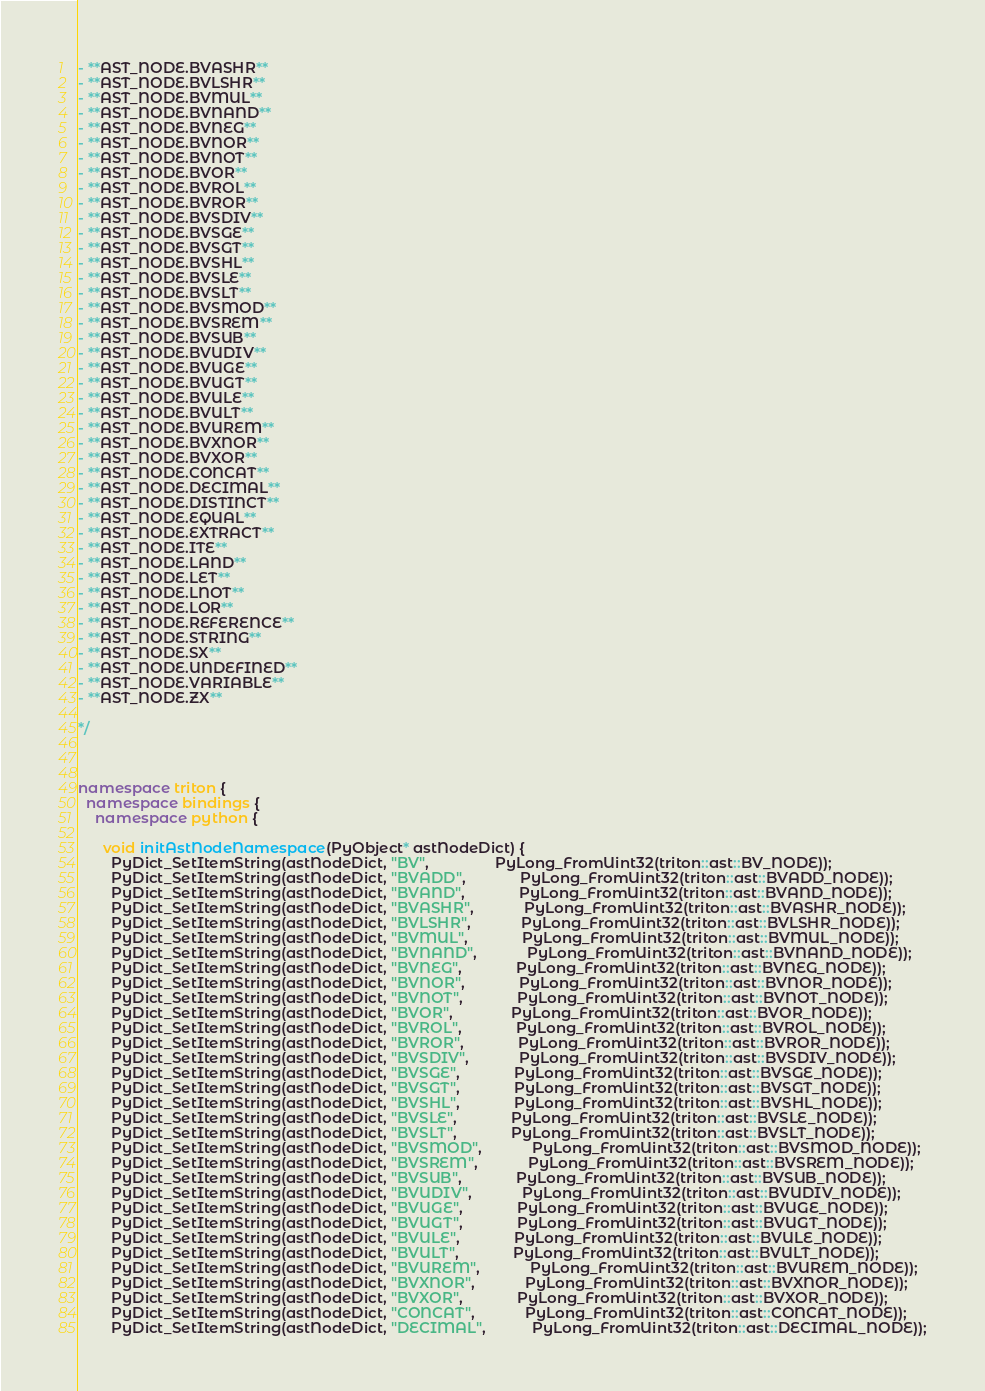<code> <loc_0><loc_0><loc_500><loc_500><_C++_>- **AST_NODE.BVASHR**
- **AST_NODE.BVLSHR**
- **AST_NODE.BVMUL**
- **AST_NODE.BVNAND**
- **AST_NODE.BVNEG**
- **AST_NODE.BVNOR**
- **AST_NODE.BVNOT**
- **AST_NODE.BVOR**
- **AST_NODE.BVROL**
- **AST_NODE.BVROR**
- **AST_NODE.BVSDIV**
- **AST_NODE.BVSGE**
- **AST_NODE.BVSGT**
- **AST_NODE.BVSHL**
- **AST_NODE.BVSLE**
- **AST_NODE.BVSLT**
- **AST_NODE.BVSMOD**
- **AST_NODE.BVSREM**
- **AST_NODE.BVSUB**
- **AST_NODE.BVUDIV**
- **AST_NODE.BVUGE**
- **AST_NODE.BVUGT**
- **AST_NODE.BVULE**
- **AST_NODE.BVULT**
- **AST_NODE.BVUREM**
- **AST_NODE.BVXNOR**
- **AST_NODE.BVXOR**
- **AST_NODE.CONCAT**
- **AST_NODE.DECIMAL**
- **AST_NODE.DISTINCT**
- **AST_NODE.EQUAL**
- **AST_NODE.EXTRACT**
- **AST_NODE.ITE**
- **AST_NODE.LAND**
- **AST_NODE.LET**
- **AST_NODE.LNOT**
- **AST_NODE.LOR**
- **AST_NODE.REFERENCE**
- **AST_NODE.STRING**
- **AST_NODE.SX**
- **AST_NODE.UNDEFINED**
- **AST_NODE.VARIABLE**
- **AST_NODE.ZX**

*/



namespace triton {
  namespace bindings {
    namespace python {

      void initAstNodeNamespace(PyObject* astNodeDict) {
        PyDict_SetItemString(astNodeDict, "BV",                PyLong_FromUint32(triton::ast::BV_NODE));
        PyDict_SetItemString(astNodeDict, "BVADD",             PyLong_FromUint32(triton::ast::BVADD_NODE));
        PyDict_SetItemString(astNodeDict, "BVAND",             PyLong_FromUint32(triton::ast::BVAND_NODE));
        PyDict_SetItemString(astNodeDict, "BVASHR",            PyLong_FromUint32(triton::ast::BVASHR_NODE));
        PyDict_SetItemString(astNodeDict, "BVLSHR",            PyLong_FromUint32(triton::ast::BVLSHR_NODE));
        PyDict_SetItemString(astNodeDict, "BVMUL",             PyLong_FromUint32(triton::ast::BVMUL_NODE));
        PyDict_SetItemString(astNodeDict, "BVNAND",            PyLong_FromUint32(triton::ast::BVNAND_NODE));
        PyDict_SetItemString(astNodeDict, "BVNEG",             PyLong_FromUint32(triton::ast::BVNEG_NODE));
        PyDict_SetItemString(astNodeDict, "BVNOR",             PyLong_FromUint32(triton::ast::BVNOR_NODE));
        PyDict_SetItemString(astNodeDict, "BVNOT",             PyLong_FromUint32(triton::ast::BVNOT_NODE));
        PyDict_SetItemString(astNodeDict, "BVOR",              PyLong_FromUint32(triton::ast::BVOR_NODE));
        PyDict_SetItemString(astNodeDict, "BVROL",             PyLong_FromUint32(triton::ast::BVROL_NODE));
        PyDict_SetItemString(astNodeDict, "BVROR",             PyLong_FromUint32(triton::ast::BVROR_NODE));
        PyDict_SetItemString(astNodeDict, "BVSDIV",            PyLong_FromUint32(triton::ast::BVSDIV_NODE));
        PyDict_SetItemString(astNodeDict, "BVSGE",             PyLong_FromUint32(triton::ast::BVSGE_NODE));
        PyDict_SetItemString(astNodeDict, "BVSGT",             PyLong_FromUint32(triton::ast::BVSGT_NODE));
        PyDict_SetItemString(astNodeDict, "BVSHL",             PyLong_FromUint32(triton::ast::BVSHL_NODE));
        PyDict_SetItemString(astNodeDict, "BVSLE",             PyLong_FromUint32(triton::ast::BVSLE_NODE));
        PyDict_SetItemString(astNodeDict, "BVSLT",             PyLong_FromUint32(triton::ast::BVSLT_NODE));
        PyDict_SetItemString(astNodeDict, "BVSMOD",            PyLong_FromUint32(triton::ast::BVSMOD_NODE));
        PyDict_SetItemString(astNodeDict, "BVSREM",            PyLong_FromUint32(triton::ast::BVSREM_NODE));
        PyDict_SetItemString(astNodeDict, "BVSUB",             PyLong_FromUint32(triton::ast::BVSUB_NODE));
        PyDict_SetItemString(astNodeDict, "BVUDIV",            PyLong_FromUint32(triton::ast::BVUDIV_NODE));
        PyDict_SetItemString(astNodeDict, "BVUGE",             PyLong_FromUint32(triton::ast::BVUGE_NODE));
        PyDict_SetItemString(astNodeDict, "BVUGT",             PyLong_FromUint32(triton::ast::BVUGT_NODE));
        PyDict_SetItemString(astNodeDict, "BVULE",             PyLong_FromUint32(triton::ast::BVULE_NODE));
        PyDict_SetItemString(astNodeDict, "BVULT",             PyLong_FromUint32(triton::ast::BVULT_NODE));
        PyDict_SetItemString(astNodeDict, "BVUREM",            PyLong_FromUint32(triton::ast::BVUREM_NODE));
        PyDict_SetItemString(astNodeDict, "BVXNOR",            PyLong_FromUint32(triton::ast::BVXNOR_NODE));
        PyDict_SetItemString(astNodeDict, "BVXOR",             PyLong_FromUint32(triton::ast::BVXOR_NODE));
        PyDict_SetItemString(astNodeDict, "CONCAT",            PyLong_FromUint32(triton::ast::CONCAT_NODE));
        PyDict_SetItemString(astNodeDict, "DECIMAL",           PyLong_FromUint32(triton::ast::DECIMAL_NODE));</code> 